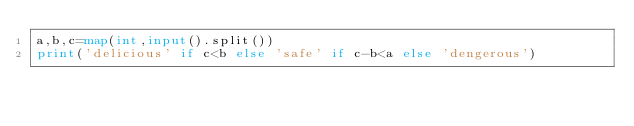<code> <loc_0><loc_0><loc_500><loc_500><_Python_>a,b,c=map(int,input().split())
print('delicious' if c<b else 'safe' if c-b<a else 'dengerous')</code> 